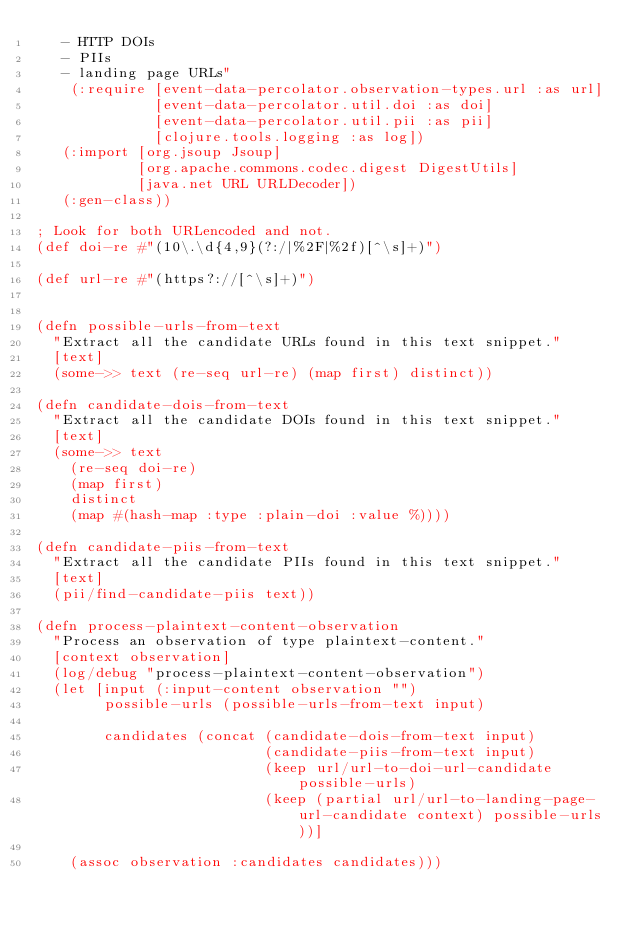Convert code to text. <code><loc_0><loc_0><loc_500><loc_500><_Clojure_>   - HTTP DOIs
   - PIIs
   - landing page URLs"
    (:require [event-data-percolator.observation-types.url :as url]
              [event-data-percolator.util.doi :as doi]
              [event-data-percolator.util.pii :as pii]
              [clojure.tools.logging :as log])
   (:import [org.jsoup Jsoup]
            [org.apache.commons.codec.digest DigestUtils]
            [java.net URL URLDecoder])
   (:gen-class))

; Look for both URLencoded and not.
(def doi-re #"(10\.\d{4,9}(?:/|%2F|%2f)[^\s]+)")

(def url-re #"(https?://[^\s]+)")


(defn possible-urls-from-text
  "Extract all the candidate URLs found in this text snippet."
  [text]
  (some->> text (re-seq url-re) (map first) distinct))

(defn candidate-dois-from-text
  "Extract all the candidate DOIs found in this text snippet."
  [text]
  (some->> text
    (re-seq doi-re)
    (map first)
    distinct
    (map #(hash-map :type :plain-doi :value %))))

(defn candidate-piis-from-text
  "Extract all the candidate PIIs found in this text snippet."
  [text]  
  (pii/find-candidate-piis text))

(defn process-plaintext-content-observation
  "Process an observation of type plaintext-content."
  [context observation]
  (log/debug "process-plaintext-content-observation")
  (let [input (:input-content observation "")
        possible-urls (possible-urls-from-text input)

        candidates (concat (candidate-dois-from-text input)
                           (candidate-piis-from-text input)
                           (keep url/url-to-doi-url-candidate possible-urls)
                           (keep (partial url/url-to-landing-page-url-candidate context) possible-urls))]
        
    (assoc observation :candidates candidates)))
</code> 